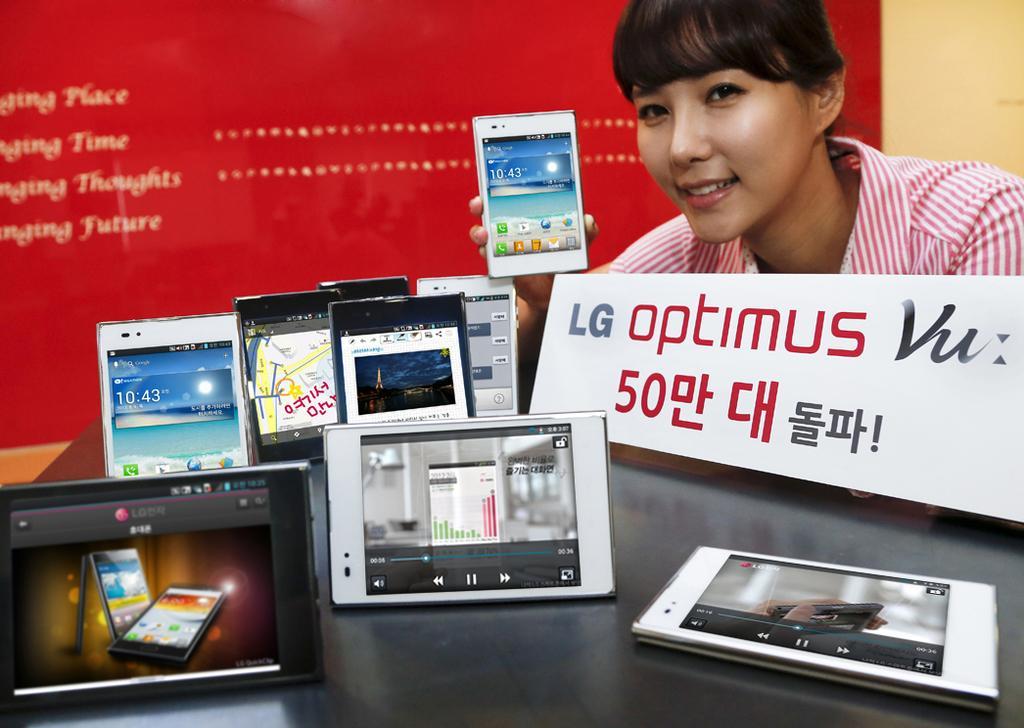Could you give a brief overview of what you see in this image? In this image I can see many mobiles and a board. To the right there is a person smiling and holding a mobile. In the background there is a banner. 